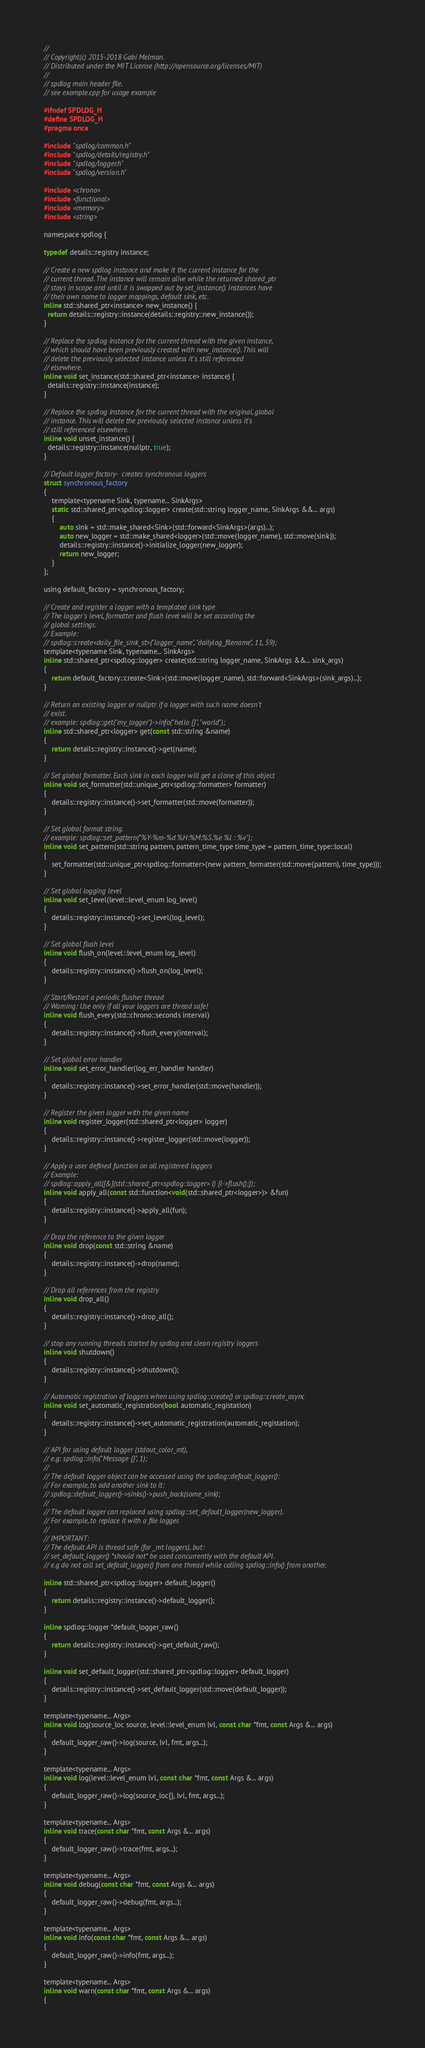<code> <loc_0><loc_0><loc_500><loc_500><_C_>//
// Copyright(c) 2015-2018 Gabi Melman.
// Distributed under the MIT License (http://opensource.org/licenses/MIT)
//
// spdlog main header file.
// see example.cpp for usage example

#ifndef SPDLOG_H
#define SPDLOG_H
#pragma once

#include "spdlog/common.h"
#include "spdlog/details/registry.h"
#include "spdlog/logger.h"
#include "spdlog/version.h"

#include <chrono>
#include <functional>
#include <memory>
#include <string>

namespace spdlog {

typedef details::registry instance;

// Create a new spdlog instance and make it the current instance for the
// current thread. The instance will remain alive while the returned shared_ptr
// stays in scope and until it is swapped out by set_instance(). Instances have
// their own name to logger mappings, default sink, etc.
inline std::shared_ptr<instance> new_instance() {
  return details::registry::instance(details::registry::new_instance());
}

// Replace the spdlog instance for the current thread with the given instance,
// which should have been previously created with new_instance(). This will
// delete the previously selected instance unless it's still referenced
// elsewhere.
inline void set_instance(std::shared_ptr<instance> instance) {
  details::registry::instance(instance);
}

// Replace the spdlog instance for the current thread with the original, global
// instance. This will delete the previously selected instance unless it's
// still referenced elsewhere.
inline void unset_instance() {
  details::registry::instance(nullptr, true);
}

// Default logger factory-  creates synchronous loggers
struct synchronous_factory
{
    template<typename Sink, typename... SinkArgs>
    static std::shared_ptr<spdlog::logger> create(std::string logger_name, SinkArgs &&... args)
    {
        auto sink = std::make_shared<Sink>(std::forward<SinkArgs>(args)...);
        auto new_logger = std::make_shared<logger>(std::move(logger_name), std::move(sink));
        details::registry::instance()->initialize_logger(new_logger);
        return new_logger;
    }
};

using default_factory = synchronous_factory;

// Create and register a logger with a templated sink type
// The logger's level, formatter and flush level will be set according the
// global settings.
// Example:
// spdlog::create<daily_file_sink_st>("logger_name", "dailylog_filename", 11, 59);
template<typename Sink, typename... SinkArgs>
inline std::shared_ptr<spdlog::logger> create(std::string logger_name, SinkArgs &&... sink_args)
{
    return default_factory::create<Sink>(std::move(logger_name), std::forward<SinkArgs>(sink_args)...);
}

// Return an existing logger or nullptr if a logger with such name doesn't
// exist.
// example: spdlog::get("my_logger")->info("hello {}", "world");
inline std::shared_ptr<logger> get(const std::string &name)
{
    return details::registry::instance()->get(name);
}

// Set global formatter. Each sink in each logger will get a clone of this object
inline void set_formatter(std::unique_ptr<spdlog::formatter> formatter)
{
    details::registry::instance()->set_formatter(std::move(formatter));
}

// Set global format string.
// example: spdlog::set_pattern("%Y-%m-%d %H:%M:%S.%e %l : %v");
inline void set_pattern(std::string pattern, pattern_time_type time_type = pattern_time_type::local)
{
    set_formatter(std::unique_ptr<spdlog::formatter>(new pattern_formatter(std::move(pattern), time_type)));
}

// Set global logging level
inline void set_level(level::level_enum log_level)
{
    details::registry::instance()->set_level(log_level);
}

// Set global flush level
inline void flush_on(level::level_enum log_level)
{
    details::registry::instance()->flush_on(log_level);
}

// Start/Restart a periodic flusher thread
// Warning: Use only if all your loggers are thread safe!
inline void flush_every(std::chrono::seconds interval)
{
    details::registry::instance()->flush_every(interval);
}

// Set global error handler
inline void set_error_handler(log_err_handler handler)
{
    details::registry::instance()->set_error_handler(std::move(handler));
}

// Register the given logger with the given name
inline void register_logger(std::shared_ptr<logger> logger)
{
    details::registry::instance()->register_logger(std::move(logger));
}

// Apply a user defined function on all registered loggers
// Example:
// spdlog::apply_all([&](std::shared_ptr<spdlog::logger> l) {l->flush();});
inline void apply_all(const std::function<void(std::shared_ptr<logger>)> &fun)
{
    details::registry::instance()->apply_all(fun);
}

// Drop the reference to the given logger
inline void drop(const std::string &name)
{
    details::registry::instance()->drop(name);
}

// Drop all references from the registry
inline void drop_all()
{
    details::registry::instance()->drop_all();
}

// stop any running threads started by spdlog and clean registry loggers
inline void shutdown()
{
    details::registry::instance()->shutdown();
}

// Automatic registration of loggers when using spdlog::create() or spdlog::create_async
inline void set_automatic_registration(bool automatic_registation)
{
    details::registry::instance()->set_automatic_registration(automatic_registation);
}

// API for using default logger (stdout_color_mt),
// e.g: spdlog::info("Message {}", 1);
//
// The default logger object can be accessed using the spdlog::default_logger():
// For example, to add another sink to it:
// spdlog::default_logger()->sinks()->push_back(some_sink);
//
// The default logger can replaced using spdlog::set_default_logger(new_logger).
// For example, to replace it with a file logger.
//
// IMPORTANT:
// The default API is thread safe (for _mt loggers), but:
// set_default_logger() *should not* be used concurrently with the default API.
// e.g do not call set_default_logger() from one thread while calling spdlog::info() from another.

inline std::shared_ptr<spdlog::logger> default_logger()
{
    return details::registry::instance()->default_logger();
}

inline spdlog::logger *default_logger_raw()
{
    return details::registry::instance()->get_default_raw();
}

inline void set_default_logger(std::shared_ptr<spdlog::logger> default_logger)
{
    details::registry::instance()->set_default_logger(std::move(default_logger));
}

template<typename... Args>
inline void log(source_loc source, level::level_enum lvl, const char *fmt, const Args &... args)
{
    default_logger_raw()->log(source, lvl, fmt, args...);
}

template<typename... Args>
inline void log(level::level_enum lvl, const char *fmt, const Args &... args)
{
    default_logger_raw()->log(source_loc{}, lvl, fmt, args...);
}

template<typename... Args>
inline void trace(const char *fmt, const Args &... args)
{
    default_logger_raw()->trace(fmt, args...);
}

template<typename... Args>
inline void debug(const char *fmt, const Args &... args)
{
    default_logger_raw()->debug(fmt, args...);
}

template<typename... Args>
inline void info(const char *fmt, const Args &... args)
{
    default_logger_raw()->info(fmt, args...);
}

template<typename... Args>
inline void warn(const char *fmt, const Args &... args)
{</code> 